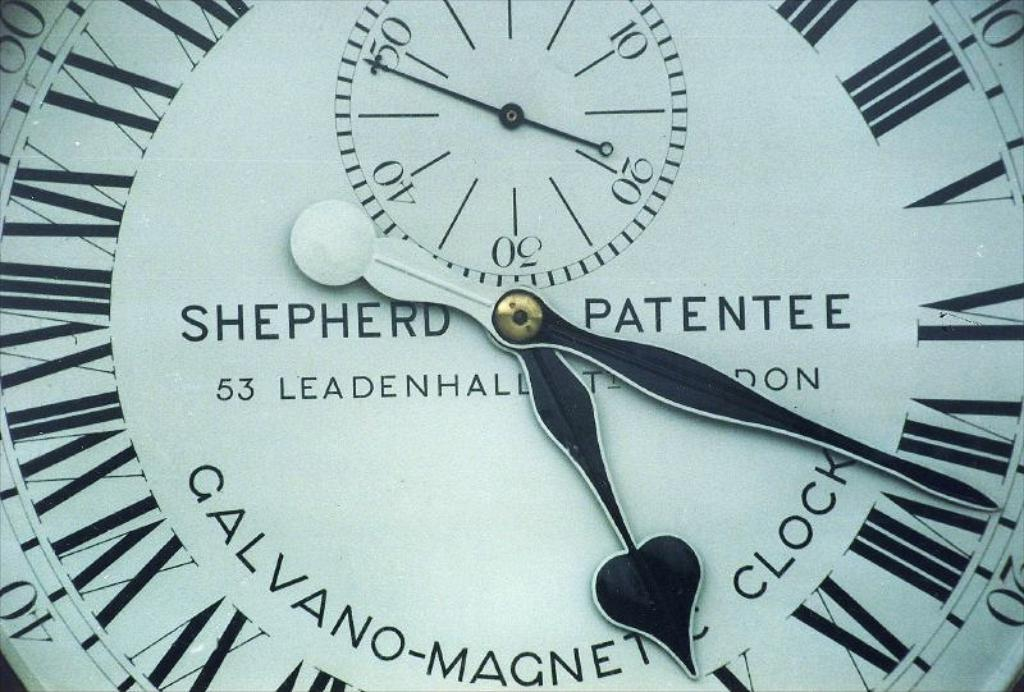<image>
Present a compact description of the photo's key features. The beautiful clock face shown was made by Shepherd Patentee. 